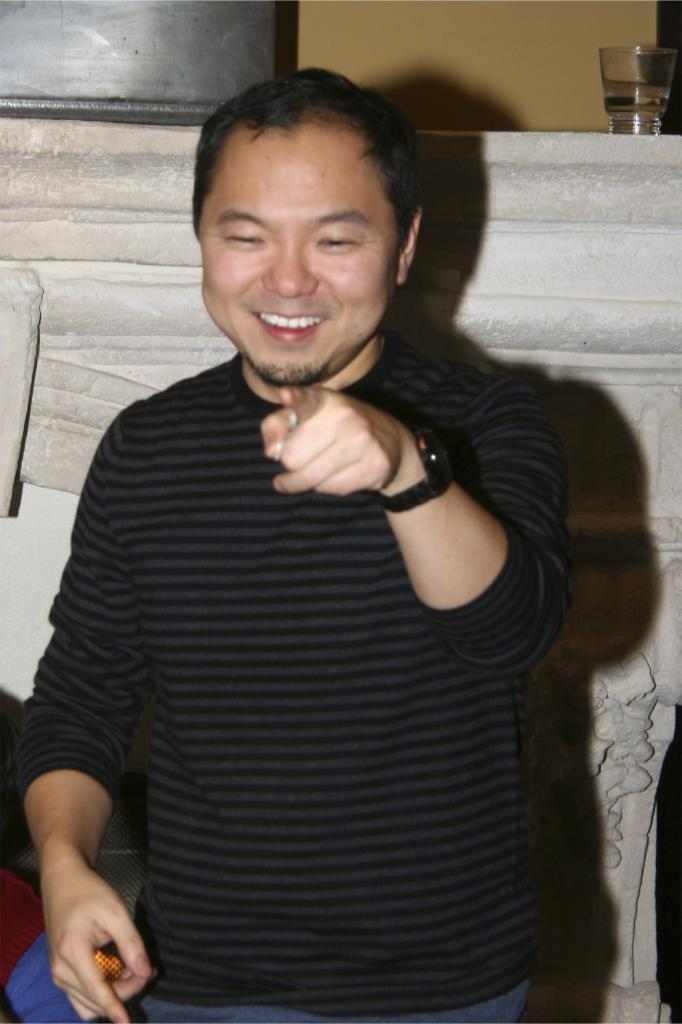What is the main subject in the foreground of the picture? There is a man in the foreground of the picture. What is the man wearing? The man is wearing a black suit. What is the man's facial expression? The man is smiling. What can be seen in the background of the picture? There is a stone, a container, a glass, and a wall in the background of the picture. What type of drum can be heard playing in the background of the image? There is no drum or sound present in the image; it is a still photograph. 